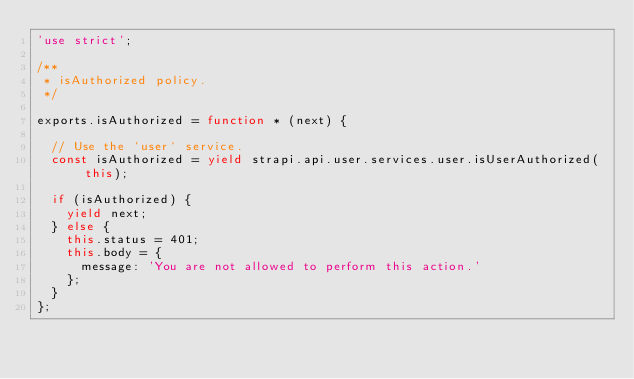Convert code to text. <code><loc_0><loc_0><loc_500><loc_500><_JavaScript_>'use strict';

/**
 * isAuthorized policy.
 */

exports.isAuthorized = function * (next) {

  // Use the `user` service.
  const isAuthorized = yield strapi.api.user.services.user.isUserAuthorized(this);

  if (isAuthorized) {
    yield next;
  } else {
    this.status = 401;
    this.body = {
      message: 'You are not allowed to perform this action.'
    };
  }
};
</code> 